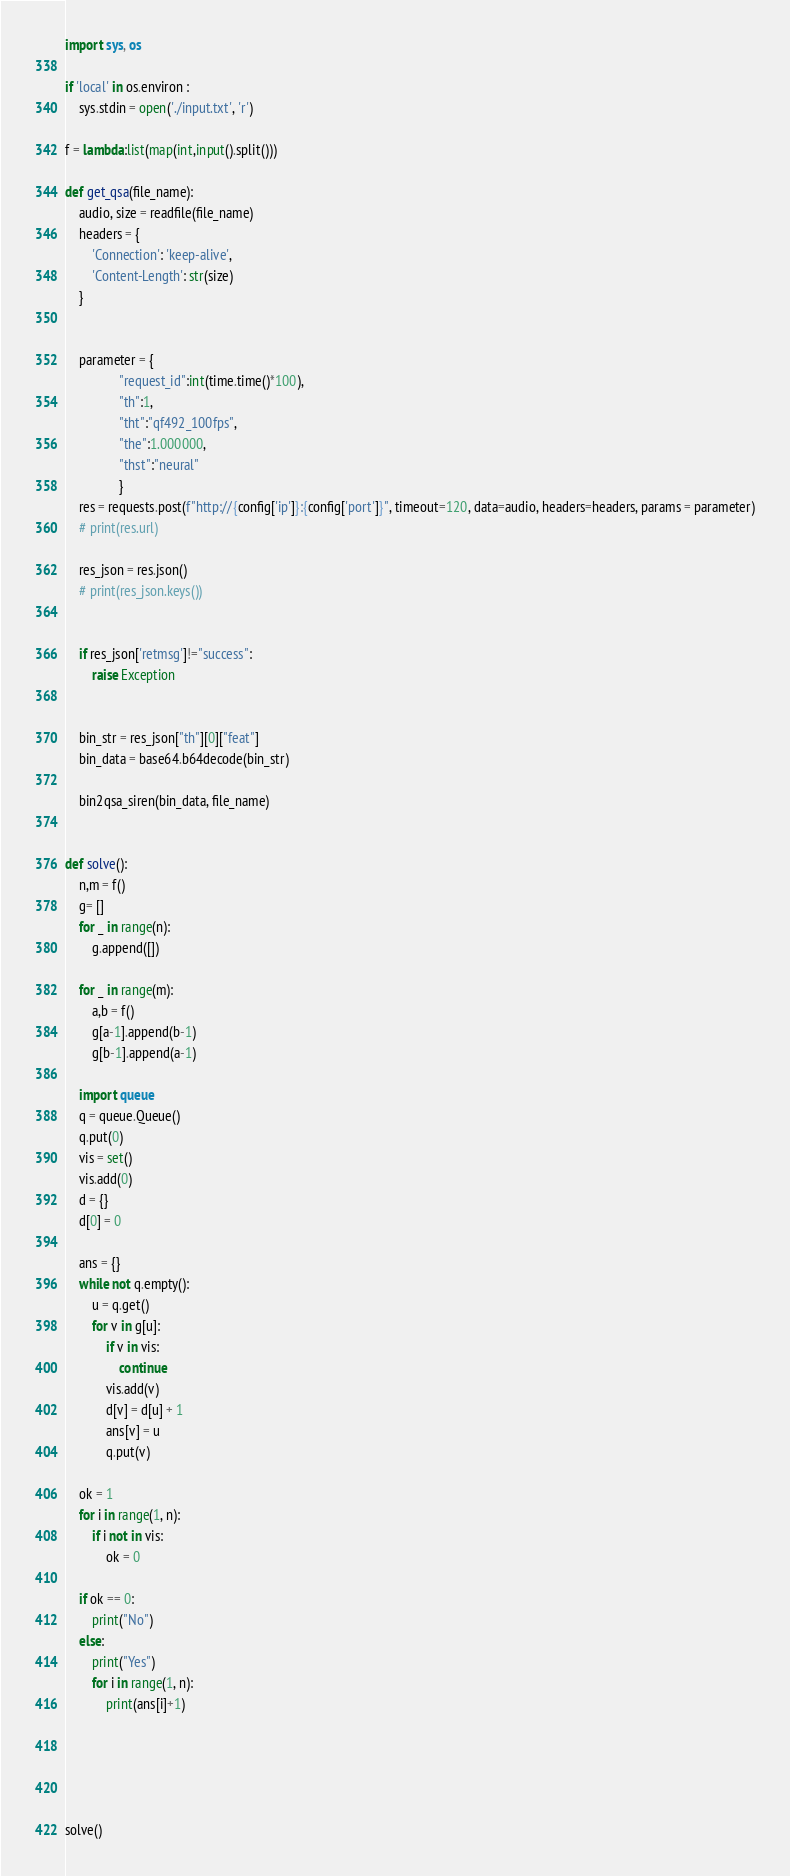Convert code to text. <code><loc_0><loc_0><loc_500><loc_500><_Python_>import sys, os

if 'local' in os.environ :
    sys.stdin = open('./input.txt', 'r')

f = lambda:list(map(int,input().split()))

def get_qsa(file_name):
    audio, size = readfile(file_name)
    headers = {
        'Connection': 'keep-alive',
        'Content-Length': str(size)
    }

    
    parameter = {
                "request_id":int(time.time()*100),
                "th":1,
                "tht":"qf492_100fps",
                "the":1.000000,
                "thst":"neural"
                }
    res = requests.post(f"http://{config['ip']}:{config['port']}", timeout=120, data=audio, headers=headers, params = parameter)
    # print(res.url)

    res_json = res.json()
    # print(res_json.keys())


    if res_json['retmsg']!="success":
        raise Exception
    

    bin_str = res_json["th"][0]["feat"]
    bin_data = base64.b64decode(bin_str)

    bin2qsa_siren(bin_data, file_name)


def solve():
    n,m = f()
    g= []
    for _ in range(n):
        g.append([])

    for _ in range(m):
        a,b = f()
        g[a-1].append(b-1)
        g[b-1].append(a-1)

    import queue
    q = queue.Queue()
    q.put(0)
    vis = set()
    vis.add(0)
    d = {}
    d[0] = 0

    ans = {}
    while not q.empty():
        u = q.get()
        for v in g[u]:
            if v in vis:
                continue
            vis.add(v)
            d[v] = d[u] + 1
            ans[v] = u
            q.put(v)

    ok = 1
    for i in range(1, n):
        if i not in vis:
            ok = 0
    
    if ok == 0:
        print("No")
    else:
        print("Yes")
        for i in range(1, n):
            print(ans[i]+1)



       
    
solve()

</code> 